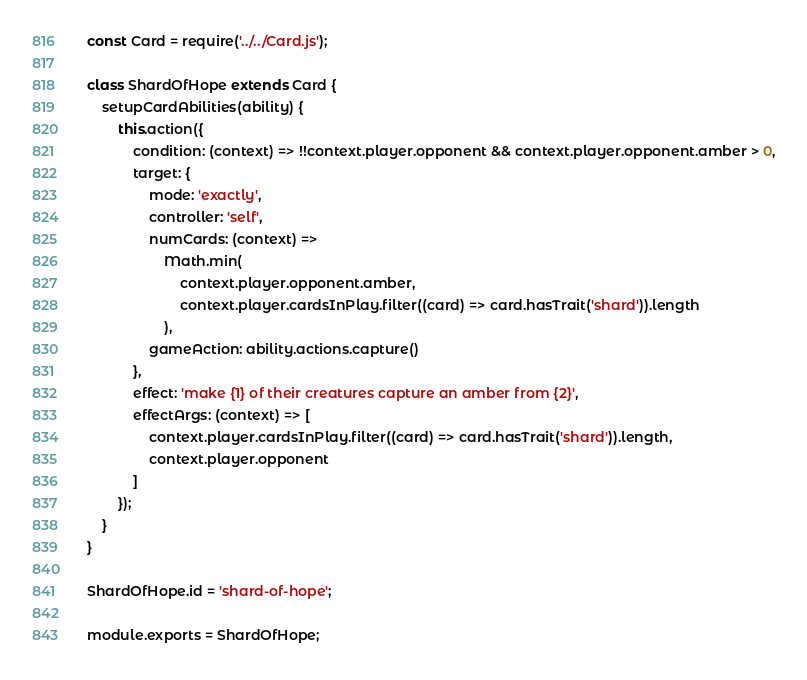Convert code to text. <code><loc_0><loc_0><loc_500><loc_500><_JavaScript_>const Card = require('../../Card.js');

class ShardOfHope extends Card {
    setupCardAbilities(ability) {
        this.action({
            condition: (context) => !!context.player.opponent && context.player.opponent.amber > 0,
            target: {
                mode: 'exactly',
                controller: 'self',
                numCards: (context) =>
                    Math.min(
                        context.player.opponent.amber,
                        context.player.cardsInPlay.filter((card) => card.hasTrait('shard')).length
                    ),
                gameAction: ability.actions.capture()
            },
            effect: 'make {1} of their creatures capture an amber from {2}',
            effectArgs: (context) => [
                context.player.cardsInPlay.filter((card) => card.hasTrait('shard')).length,
                context.player.opponent
            ]
        });
    }
}

ShardOfHope.id = 'shard-of-hope';

module.exports = ShardOfHope;
</code> 